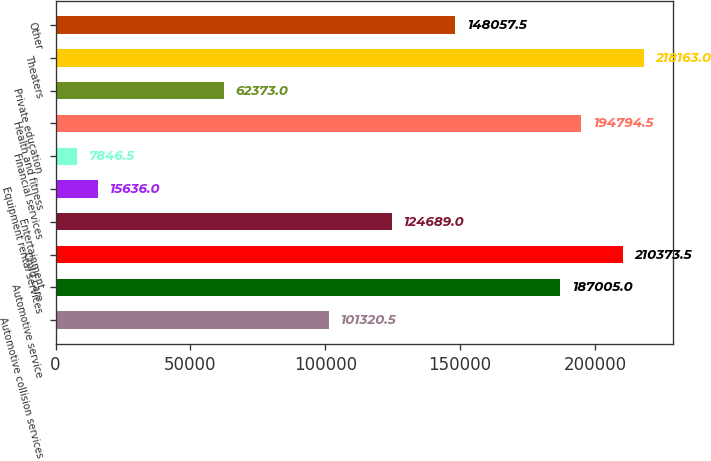<chart> <loc_0><loc_0><loc_500><loc_500><bar_chart><fcel>Automotive collision services<fcel>Automotive service<fcel>Child care<fcel>Entertainment<fcel>Equipment rental services<fcel>Financial services<fcel>Health and fitness<fcel>Private education<fcel>Theaters<fcel>Other<nl><fcel>101320<fcel>187005<fcel>210374<fcel>124689<fcel>15636<fcel>7846.5<fcel>194794<fcel>62373<fcel>218163<fcel>148058<nl></chart> 